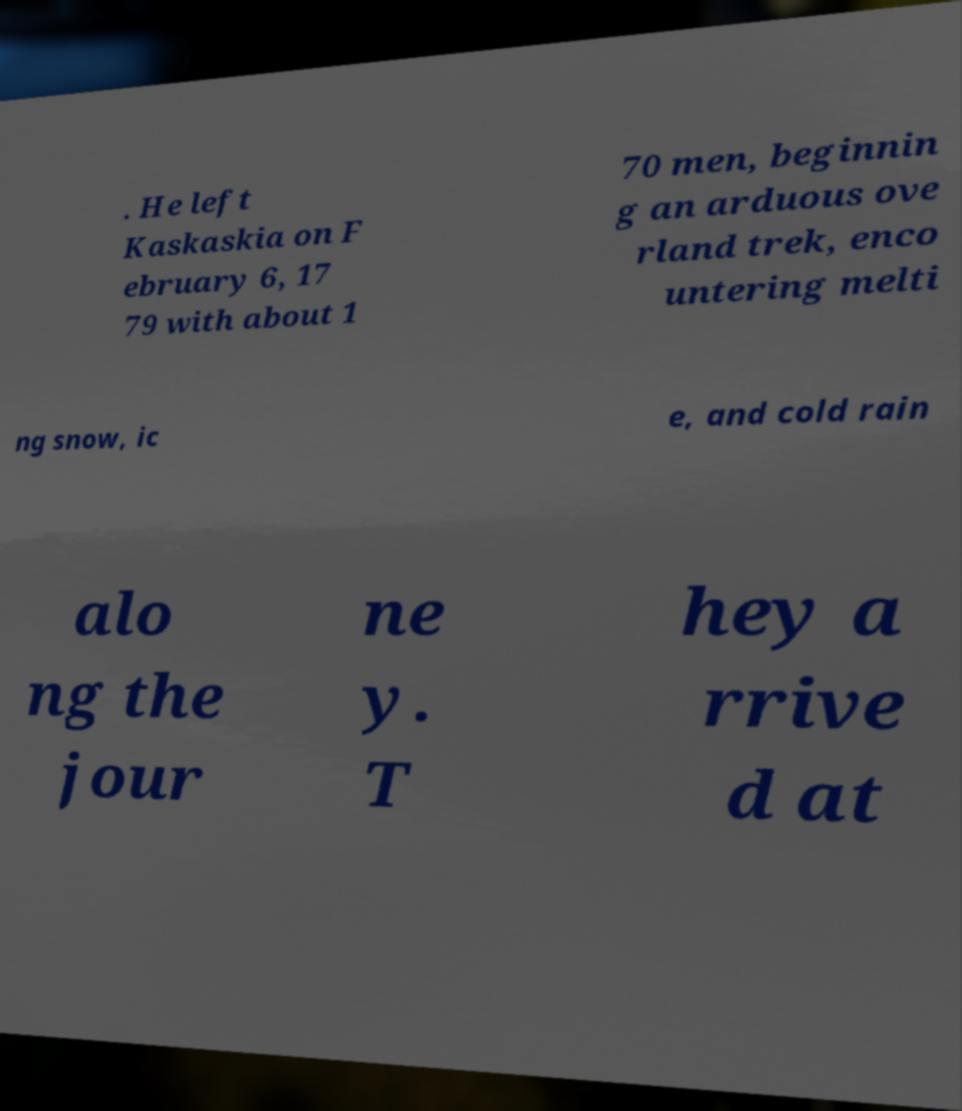Could you extract and type out the text from this image? . He left Kaskaskia on F ebruary 6, 17 79 with about 1 70 men, beginnin g an arduous ove rland trek, enco untering melti ng snow, ic e, and cold rain alo ng the jour ne y. T hey a rrive d at 